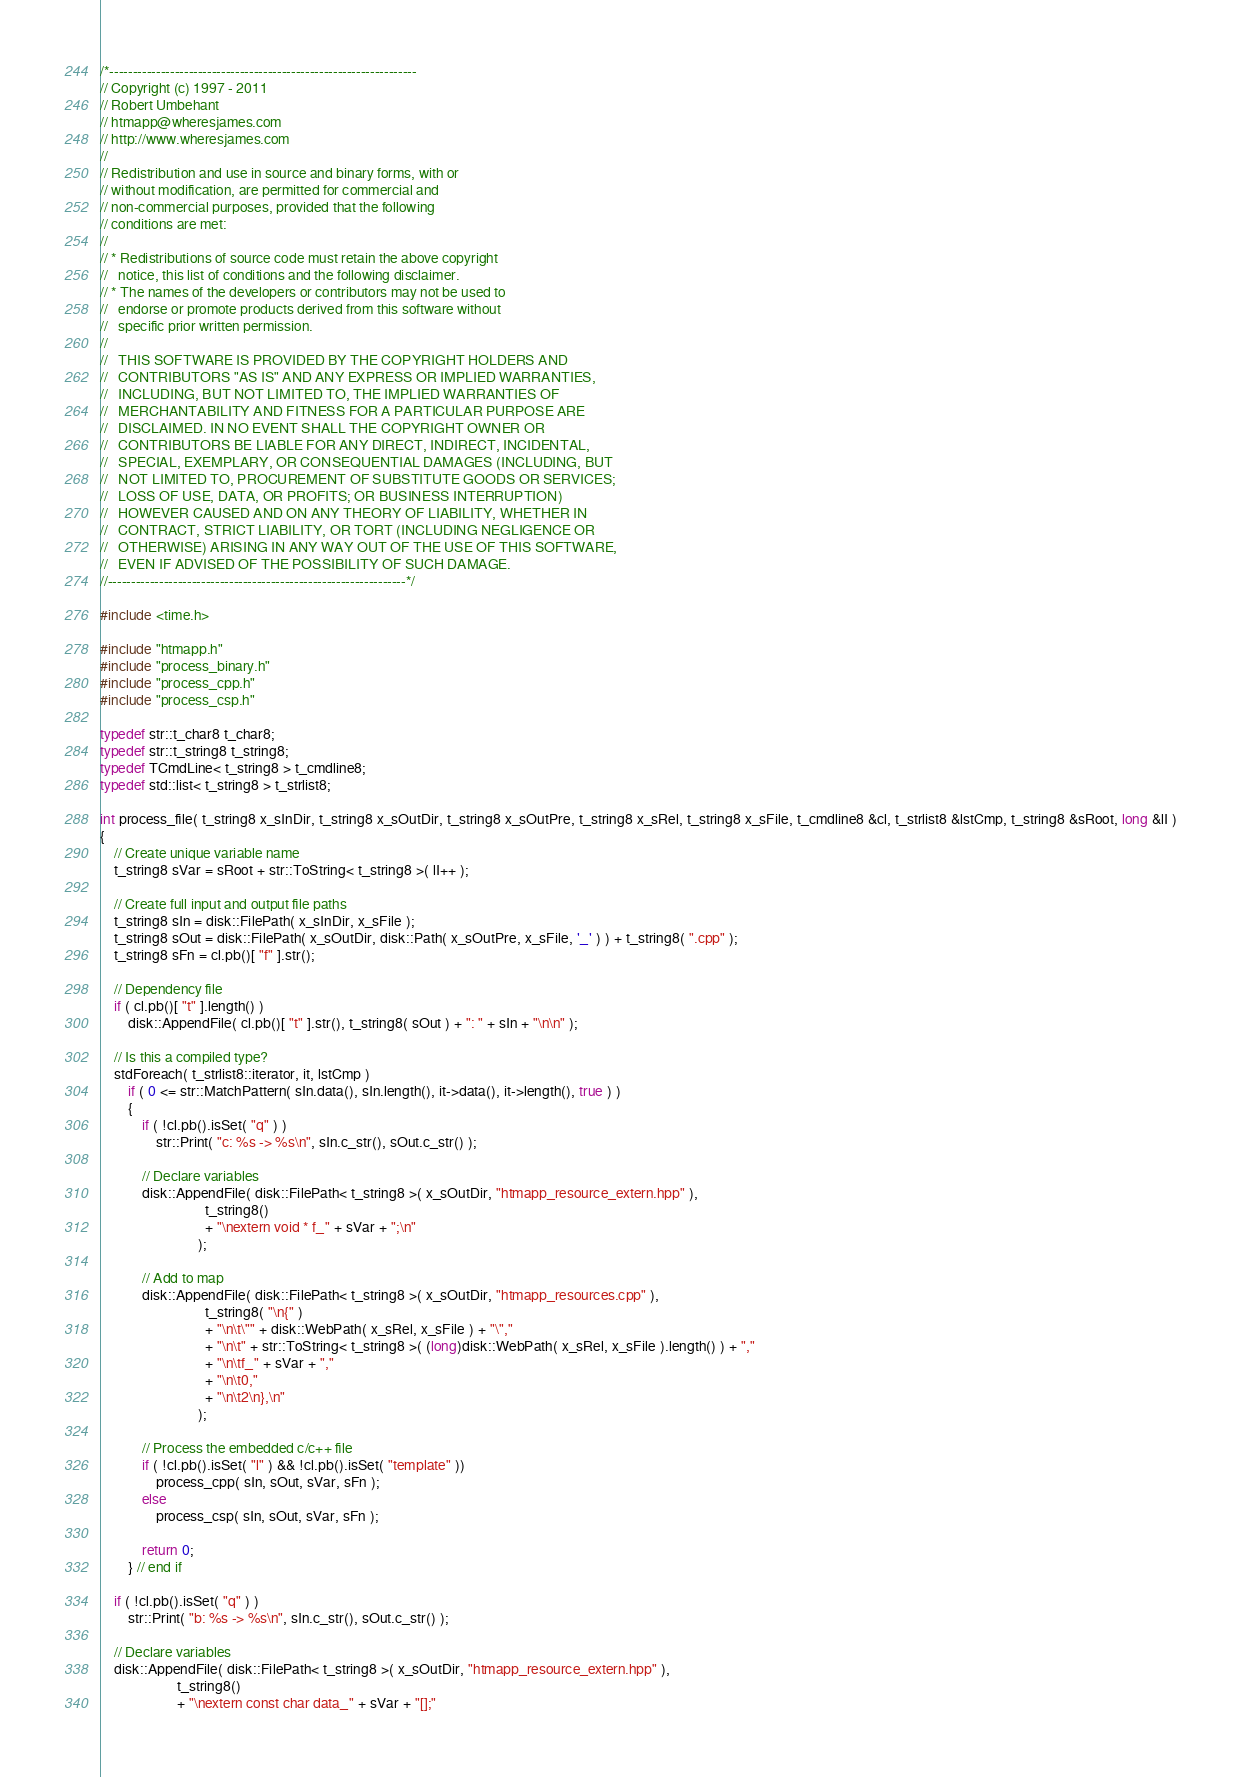Convert code to text. <code><loc_0><loc_0><loc_500><loc_500><_C++_>/*------------------------------------------------------------------
// Copyright (c) 1997 - 2011
// Robert Umbehant
// htmapp@wheresjames.com
// http://www.wheresjames.com
//
// Redistribution and use in source and binary forms, with or
// without modification, are permitted for commercial and
// non-commercial purposes, provided that the following
// conditions are met:
//
// * Redistributions of source code must retain the above copyright
//   notice, this list of conditions and the following disclaimer.
// * The names of the developers or contributors may not be used to
//   endorse or promote products derived from this software without
//   specific prior written permission.
//
//   THIS SOFTWARE IS PROVIDED BY THE COPYRIGHT HOLDERS AND
//   CONTRIBUTORS "AS IS" AND ANY EXPRESS OR IMPLIED WARRANTIES,
//   INCLUDING, BUT NOT LIMITED TO, THE IMPLIED WARRANTIES OF
//   MERCHANTABILITY AND FITNESS FOR A PARTICULAR PURPOSE ARE
//   DISCLAIMED. IN NO EVENT SHALL THE COPYRIGHT OWNER OR
//   CONTRIBUTORS BE LIABLE FOR ANY DIRECT, INDIRECT, INCIDENTAL,
//   SPECIAL, EXEMPLARY, OR CONSEQUENTIAL DAMAGES (INCLUDING, BUT
//   NOT LIMITED TO, PROCUREMENT OF SUBSTITUTE GOODS OR SERVICES;
//   LOSS OF USE, DATA, OR PROFITS; OR BUSINESS INTERRUPTION)
//   HOWEVER CAUSED AND ON ANY THEORY OF LIABILITY, WHETHER IN
//   CONTRACT, STRICT LIABILITY, OR TORT (INCLUDING NEGLIGENCE OR
//   OTHERWISE) ARISING IN ANY WAY OUT OF THE USE OF THIS SOFTWARE,
//   EVEN IF ADVISED OF THE POSSIBILITY OF SUCH DAMAGE.
//----------------------------------------------------------------*/

#include <time.h>

#include "htmapp.h"
#include "process_binary.h"
#include "process_cpp.h"
#include "process_csp.h"

typedef str::t_char8 t_char8;
typedef str::t_string8 t_string8;
typedef TCmdLine< t_string8 > t_cmdline8;
typedef std::list< t_string8 > t_strlist8;

int process_file( t_string8 x_sInDir, t_string8 x_sOutDir, t_string8 x_sOutPre, t_string8 x_sRel, t_string8 x_sFile, t_cmdline8 &cl, t_strlist8 &lstCmp, t_string8 &sRoot, long &lI )
{
	// Create unique variable name
	t_string8 sVar = sRoot + str::ToString< t_string8 >( lI++ );
	
	// Create full input and output file paths
	t_string8 sIn = disk::FilePath( x_sInDir, x_sFile );
	t_string8 sOut = disk::FilePath( x_sOutDir, disk::Path( x_sOutPre, x_sFile, '_' ) ) + t_string8( ".cpp" );
	t_string8 sFn = cl.pb()[ "f" ].str();

	// Dependency file
	if ( cl.pb()[ "t" ].length() )
		disk::AppendFile( cl.pb()[ "t" ].str(), t_string8( sOut ) + ": " + sIn + "\n\n" );

	// Is this a compiled type?
	stdForeach( t_strlist8::iterator, it, lstCmp )
		if ( 0 <= str::MatchPattern( sIn.data(), sIn.length(), it->data(), it->length(), true ) )
		{
			if ( !cl.pb().isSet( "q" ) )
				str::Print( "c: %s -> %s\n", sIn.c_str(), sOut.c_str() );

			// Declare variables
			disk::AppendFile( disk::FilePath< t_string8 >( x_sOutDir, "htmapp_resource_extern.hpp" ),
							  t_string8()
							  + "\nextern void * f_" + sVar + ";\n"
							);

			// Add to map
			disk::AppendFile( disk::FilePath< t_string8 >( x_sOutDir, "htmapp_resources.cpp" ),
							  t_string8( "\n{" )
							  + "\n\t\"" + disk::WebPath( x_sRel, x_sFile ) + "\","
							  + "\n\t" + str::ToString< t_string8 >( (long)disk::WebPath( x_sRel, x_sFile ).length() ) + ","
							  + "\n\tf_" + sVar + ","
							  + "\n\t0,"
							  + "\n\t2\n},\n"
							);
			
			// Process the embedded c/c++ file
			if ( !cl.pb().isSet( "l" ) && !cl.pb().isSet( "template" ))
				process_cpp( sIn, sOut, sVar, sFn );
			else
				process_csp( sIn, sOut, sVar, sFn );
				
			return 0;
		} // end if
		
	if ( !cl.pb().isSet( "q" ) )
		str::Print( "b: %s -> %s\n", sIn.c_str(), sOut.c_str() );

	// Declare variables
	disk::AppendFile( disk::FilePath< t_string8 >( x_sOutDir, "htmapp_resource_extern.hpp" ),
					  t_string8()
					  + "\nextern const char data_" + sVar + "[];"</code> 